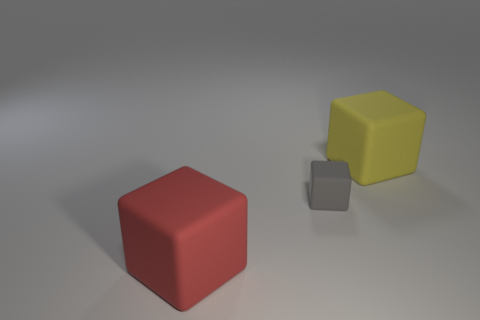Subtract all big yellow cubes. How many cubes are left? 2 Subtract 2 blocks. How many blocks are left? 1 Add 2 big brown cylinders. How many objects exist? 5 Subtract all yellow blocks. How many blocks are left? 2 Subtract 0 green cubes. How many objects are left? 3 Subtract all green blocks. Subtract all yellow cylinders. How many blocks are left? 3 Subtract all green cylinders. How many yellow blocks are left? 1 Subtract all small gray things. Subtract all large blue rubber spheres. How many objects are left? 2 Add 2 large yellow rubber objects. How many large yellow rubber objects are left? 3 Add 1 large red objects. How many large red objects exist? 2 